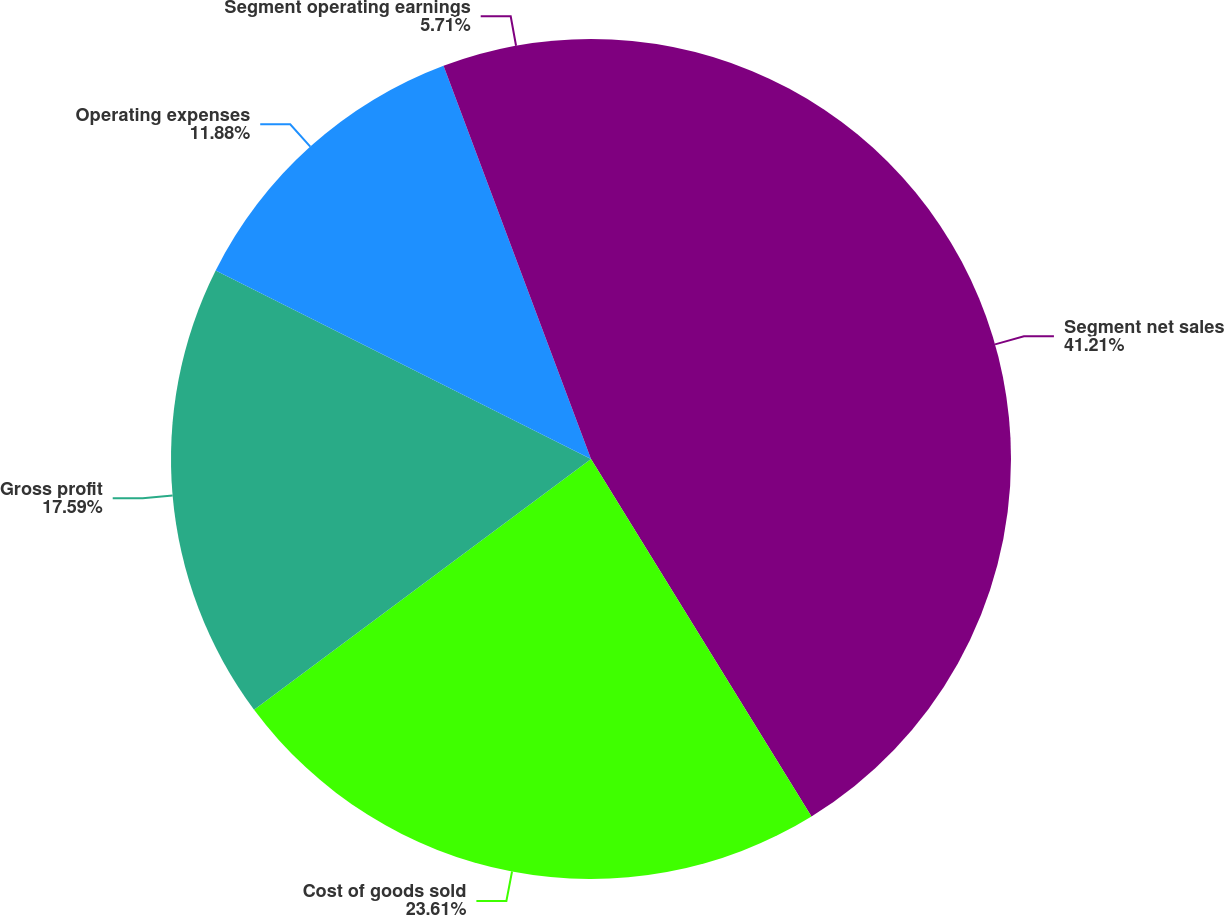<chart> <loc_0><loc_0><loc_500><loc_500><pie_chart><fcel>Segment net sales<fcel>Cost of goods sold<fcel>Gross profit<fcel>Operating expenses<fcel>Segment operating earnings<nl><fcel>41.2%<fcel>23.61%<fcel>17.59%<fcel>11.88%<fcel>5.71%<nl></chart> 